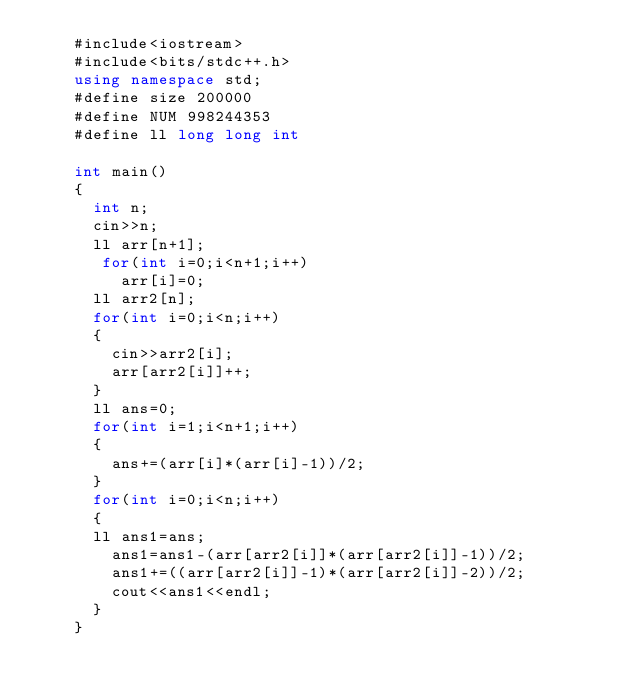Convert code to text. <code><loc_0><loc_0><loc_500><loc_500><_C++_>    #include<iostream>
    #include<bits/stdc++.h>
    using namespace std;
    #define size 200000
    #define NUM 998244353
    #define ll long long int
     
    int main()
    {
      int n;
      cin>>n;
      ll arr[n+1];
       for(int i=0;i<n+1;i++)
         arr[i]=0;
      ll arr2[n];
      for(int i=0;i<n;i++)
      {
        cin>>arr2[i];
        arr[arr2[i]]++;
      }
      ll ans=0;
      for(int i=1;i<n+1;i++)
      {
        ans+=(arr[i]*(arr[i]-1))/2;
      }
      for(int i=0;i<n;i++)
      {
    	ll ans1=ans;
        ans1=ans1-(arr[arr2[i]]*(arr[arr2[i]]-1))/2;
        ans1+=((arr[arr2[i]]-1)*(arr[arr2[i]]-2))/2;
        cout<<ans1<<endl;
      }
    }</code> 